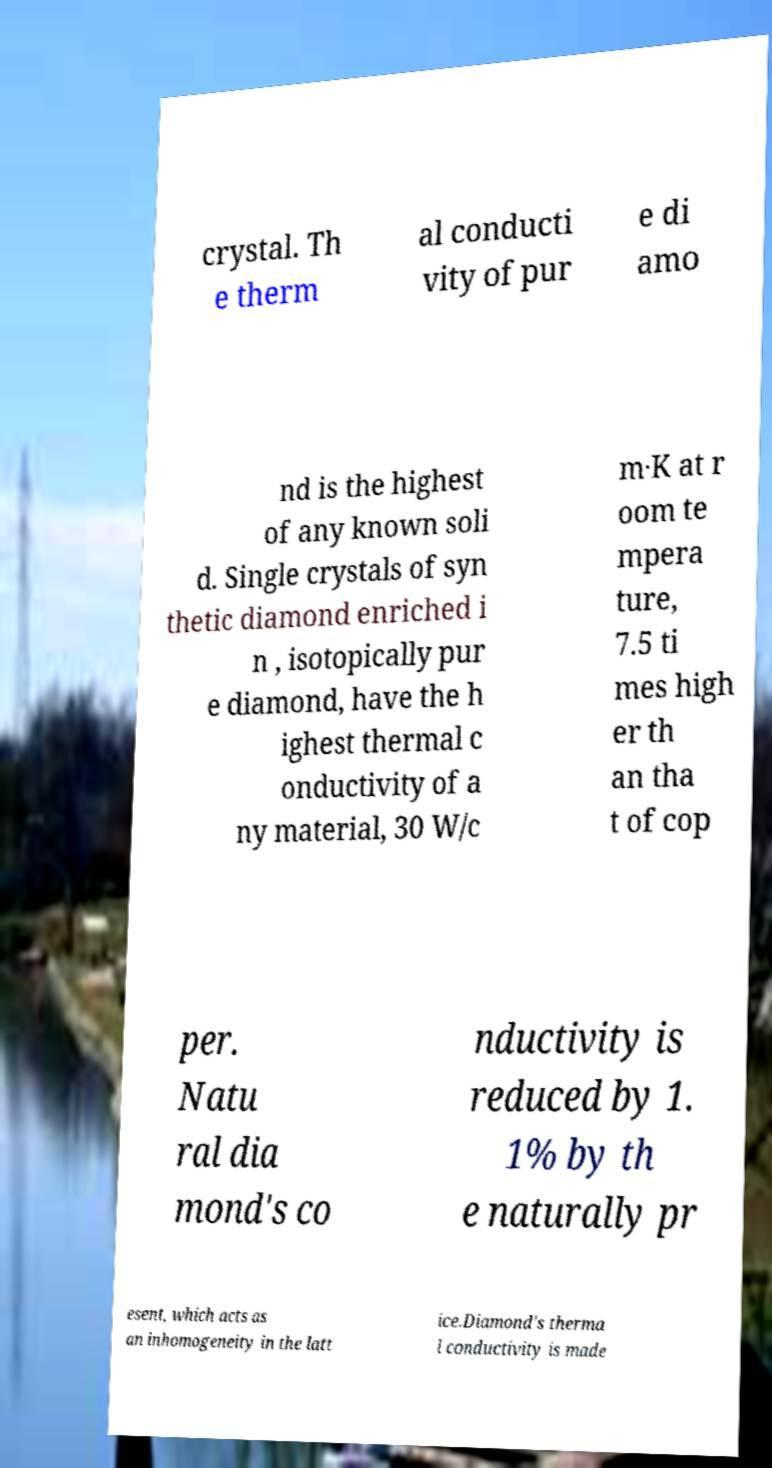I need the written content from this picture converted into text. Can you do that? crystal. Th e therm al conducti vity of pur e di amo nd is the highest of any known soli d. Single crystals of syn thetic diamond enriched i n , isotopically pur e diamond, have the h ighest thermal c onductivity of a ny material, 30 W/c m·K at r oom te mpera ture, 7.5 ti mes high er th an tha t of cop per. Natu ral dia mond's co nductivity is reduced by 1. 1% by th e naturally pr esent, which acts as an inhomogeneity in the latt ice.Diamond's therma l conductivity is made 